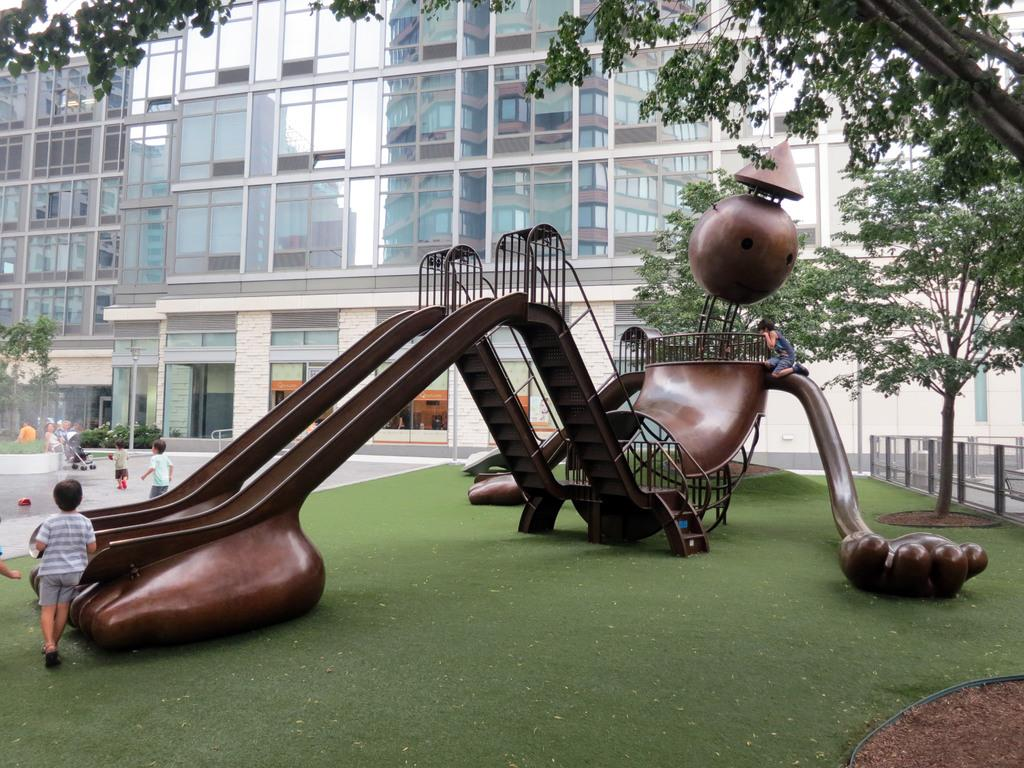What is on the ground in the image? There is a slide on the ground in the image. Who is present in the image? There are children standing in the image. What type of buildings can be seen on the left side of the image? There are glass buildings on the left side of the image. Can you identify any specific features in the image? There is a door visible in the image. What type of vegetation is on the right side of the image? There are many trees on the right side of the image. What type of pest can be seen crawling on the bed in the image? There is no bed present in the image, and therefore no pest can be observed. What type of hospital is visible in the image? There is no hospital present in the image. 